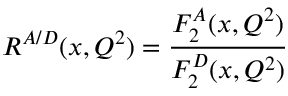Convert formula to latex. <formula><loc_0><loc_0><loc_500><loc_500>R ^ { A / D } ( x , Q ^ { 2 } ) = \frac { F _ { 2 } ^ { A } ( x , Q ^ { 2 } ) } { F _ { 2 } ^ { D } ( x , Q ^ { 2 } ) }</formula> 